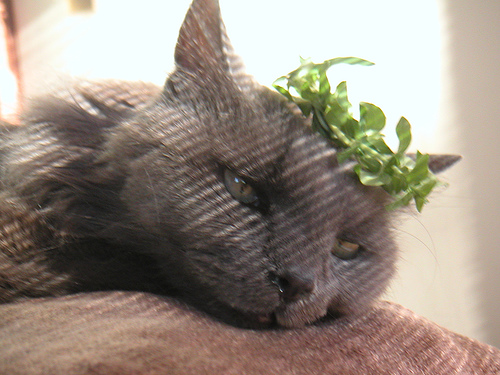<image>
Can you confirm if the plant is in the cat? No. The plant is not contained within the cat. These objects have a different spatial relationship. Where is the green leaves in relation to the cat? Is it in front of the cat? No. The green leaves is not in front of the cat. The spatial positioning shows a different relationship between these objects. 